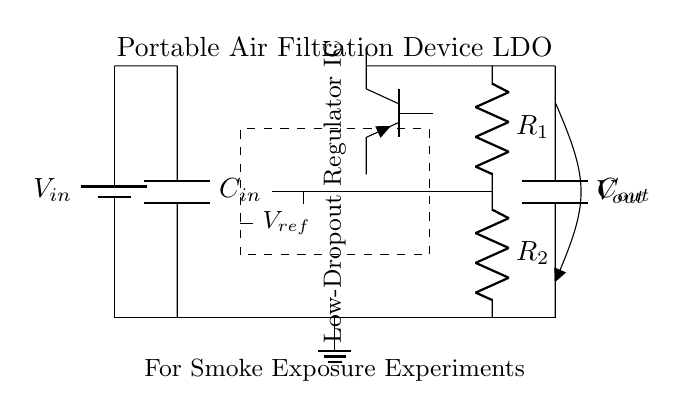What is the function of the C_in capacitor? C_in is an input capacitor that stabilizes the input voltage to the low-dropout regulator, ensuring a smooth and steady supply for its operation.
Answer: Input capacitor What is the output voltage of this circuit? The output voltage is generally defined as V_out, and its specific value is determined by the feedback network resistors R1 and R2, but it isn’t specified in the diagram.
Answer: V_out How many resistors are in the feedback network? The feedback network consists of two resistors labeled R1 and R2, which work together to set the output voltage of the regulator.
Answer: Two What type of transistor is used in the regulator? The circuit uses a PNP transistor as the pass element, which is indicated by the symbol Tpnp. This type allows for low dropout and efficient regulation.
Answer: PNP transistor What is the reference voltage for the error amplifier? The reference voltage labeled V_ref is used by the error amplifier to compare with the output voltage, providing feedback for accurate voltage regulation.
Answer: V_ref Why is it called a low-dropout regulator? It is named "low-dropout" because it can maintain the required output voltage with a very small difference (dropout voltage) between the input and output voltages, increasing efficiency in portable applications.
Answer: Low-dropout 